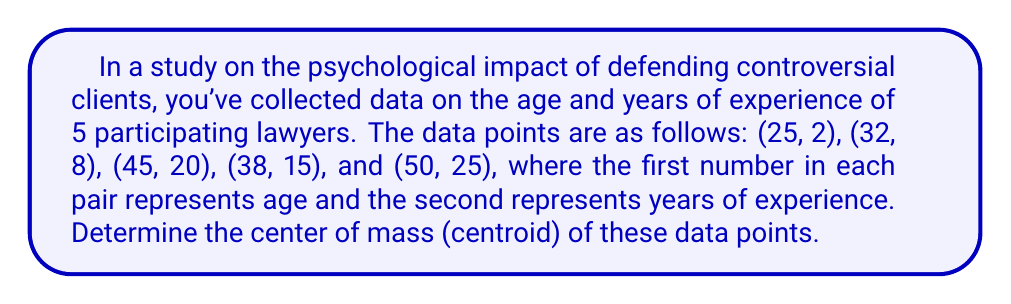Provide a solution to this math problem. To find the center of mass (centroid) of a set of data points, we need to calculate the average of the x-coordinates and y-coordinates separately. In this case, x represents age and y represents years of experience.

1. Calculate the average x-coordinate (age):
   $$\bar{x} = \frac{\sum_{i=1}^n x_i}{n} = \frac{25 + 32 + 45 + 38 + 50}{5} = \frac{190}{5} = 38$$

2. Calculate the average y-coordinate (years of experience):
   $$\bar{y} = \frac{\sum_{i=1}^n y_i}{n} = \frac{2 + 8 + 20 + 15 + 25}{5} = \frac{70}{5} = 14$$

3. The center of mass is the point $(\bar{x}, \bar{y})$, which represents the average age and average years of experience of the participating lawyers.

[asy]
size(200);
real xmin = 20, xmax = 55, ymin = 0, ymax = 30;
draw((xmin,0)--(xmax,0),Arrow);
draw((0,ymin)--(0,ymax),Arrow);

label("Age",(xmax,0),E);
label("Experience",(0,ymax),N);

dot((25,2));
dot((32,8));
dot((45,20));
dot((38,15));
dot((50,25));

dot((38,14),red);
label("(38, 14)",(38,14),NE,red);
[/asy]
Answer: The center of mass (centroid) of the data points is $(38, 14)$. 